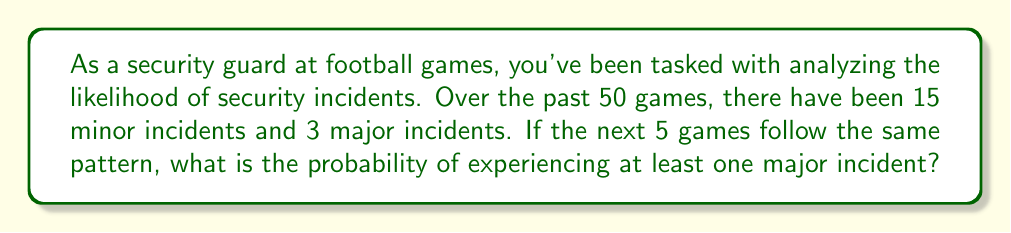Give your solution to this math problem. Let's approach this step-by-step:

1) First, we need to calculate the probability of a major incident occurring in a single game:
   $$P(\text{major incident}) = \frac{3}{50} = 0.06$$

2) The probability of no major incident in a single game is:
   $$P(\text{no major incident}) = 1 - 0.06 = 0.94$$

3) For 5 games, we want the probability of at least one major incident. This is easier to calculate by first finding the probability of no major incidents in all 5 games and then subtracting from 1:

   $$P(\text{at least one major incident}) = 1 - P(\text{no major incidents in 5 games})$$

4) The probability of no major incidents in 5 games is:
   $$P(\text{no major incidents in 5 games}) = (0.94)^5 = 0.7350$$

5) Therefore, the probability of at least one major incident in 5 games is:
   $$P(\text{at least one major incident}) = 1 - 0.7350 = 0.2650$$

6) Converting to a percentage:
   $$0.2650 \times 100\% = 26.50\%$$
Answer: 26.50% 